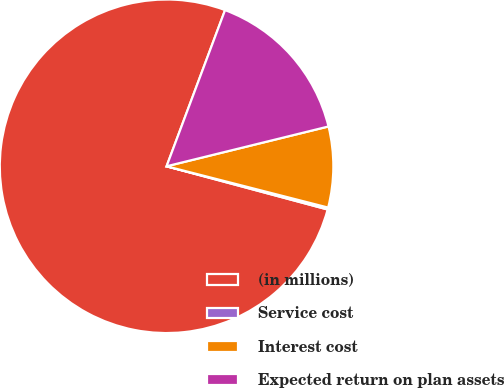Convert chart to OTSL. <chart><loc_0><loc_0><loc_500><loc_500><pie_chart><fcel>(in millions)<fcel>Service cost<fcel>Interest cost<fcel>Expected return on plan assets<nl><fcel>76.53%<fcel>0.19%<fcel>7.82%<fcel>15.46%<nl></chart> 